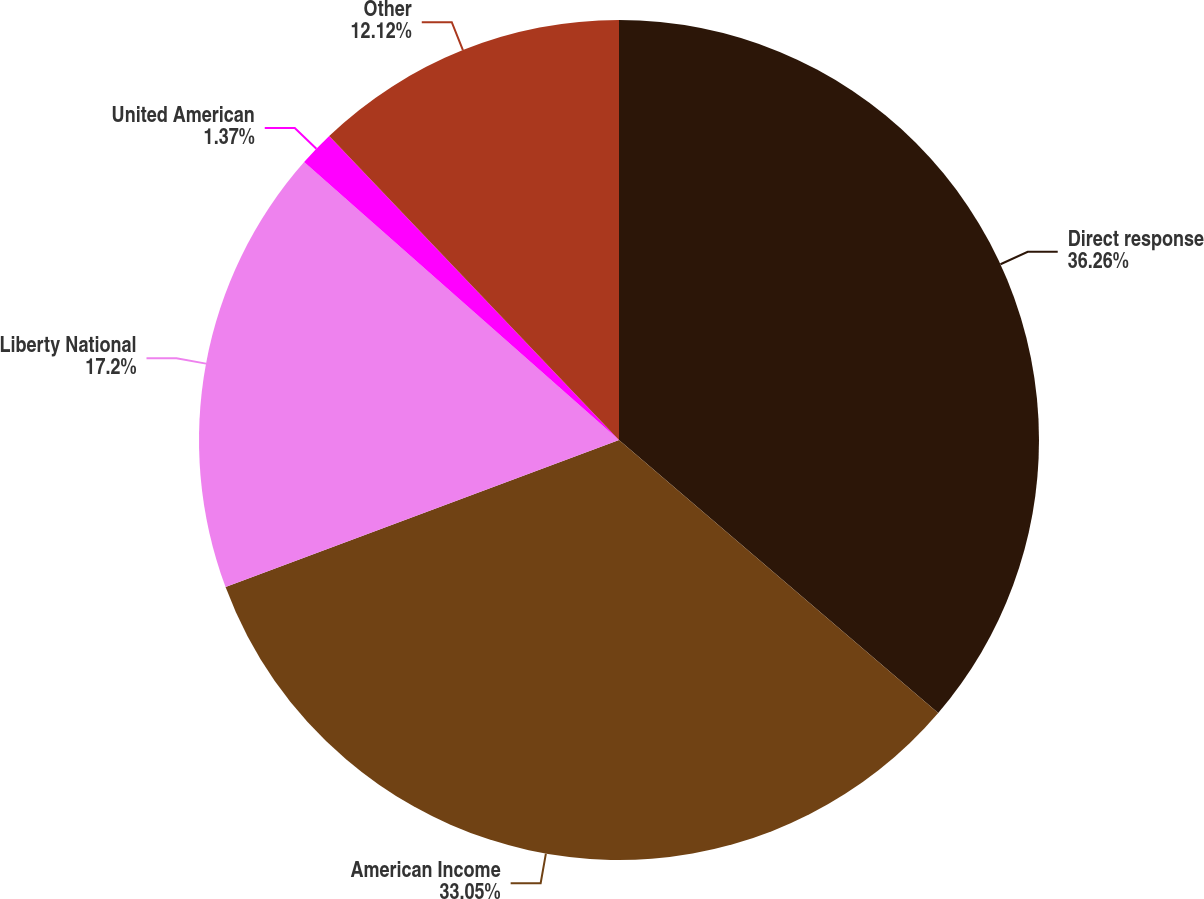<chart> <loc_0><loc_0><loc_500><loc_500><pie_chart><fcel>Direct response<fcel>American Income<fcel>Liberty National<fcel>United American<fcel>Other<nl><fcel>36.26%<fcel>33.05%<fcel>17.2%<fcel>1.37%<fcel>12.12%<nl></chart> 